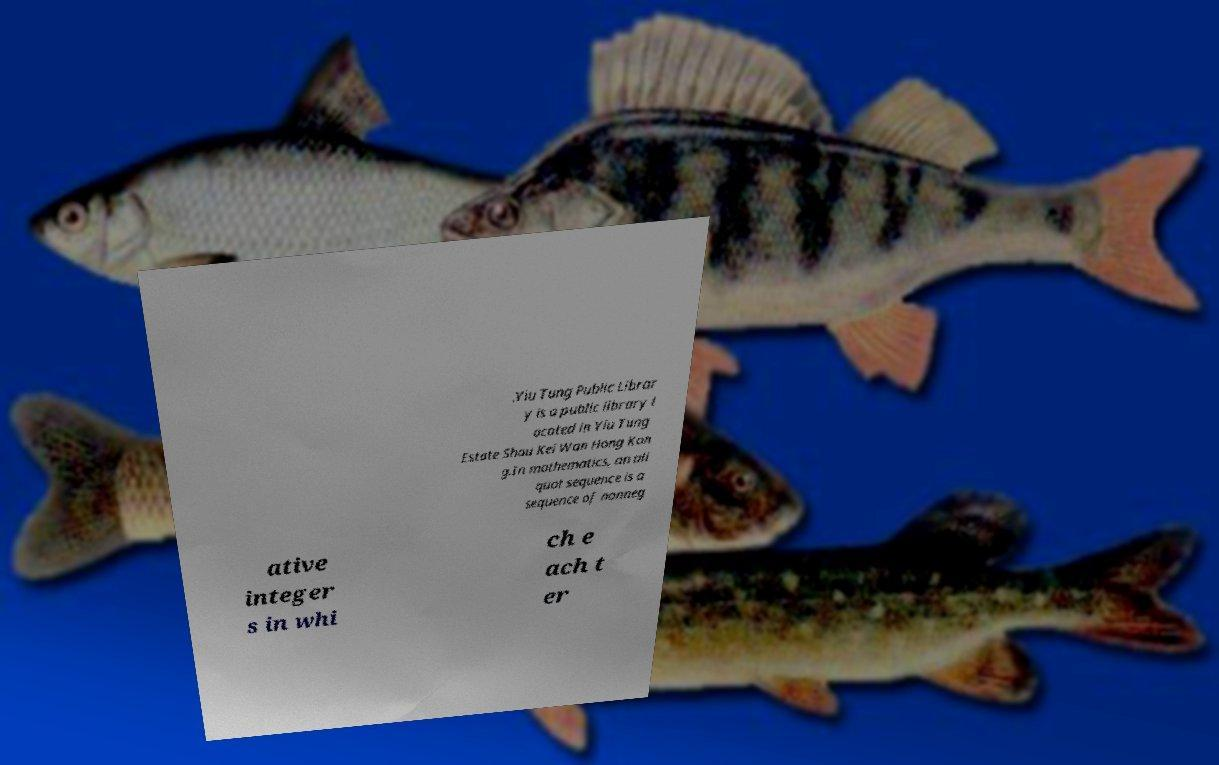What messages or text are displayed in this image? I need them in a readable, typed format. .Yiu Tung Public Librar y is a public library l ocated in Yiu Tung Estate Shau Kei Wan Hong Kon g.In mathematics, an ali quot sequence is a sequence of nonneg ative integer s in whi ch e ach t er 